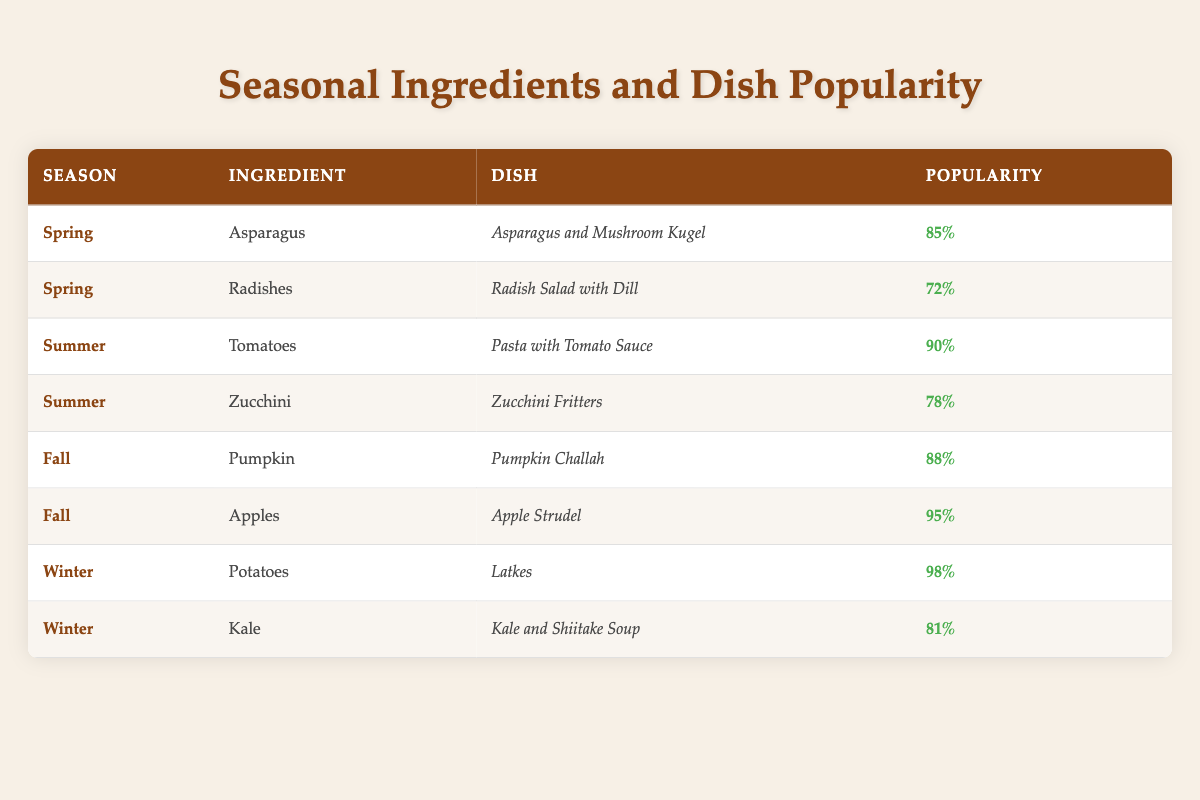What dish has the highest popularity in Spring? The table shows that "Asparagus and Mushroom Kugel" has a popularity of 85%, while "Radish Salad with Dill" has a popularity of 72%. Since 85% is higher than 72%, the dish with the highest popularity in Spring is "Asparagus and Mushroom Kugel."
Answer: Asparagus and Mushroom Kugel What is the popularity of the dish "Apple Strudel"? Looking at the table, "Apple Strudel" is listed under Fall with a popularity of 95%.
Answer: 95% Which season features the ingredient "Zucchini"? The table provides information that "Zucchini" is used in the dish "Zucchini Fritters," which is listed under Summer.
Answer: Summer Is "Latkes" more popular than "Kale and Shiitake Soup"? "Latkes" have a popularity rating of 98%, while "Kale and Shiitake Soup" has 81%. Since 98% is greater than 81%, it is true that "Latkes" are more popular.
Answer: Yes What is the average popularity of dishes in Winter? The popularity ratings for Winter are 98% for "Latkes" and 81% for "Kale and Shiitake Soup." To find the average, we add these two values together: 98 + 81 = 179. Then, we divide the sum by the number of dishes (2): 179 / 2 = 89.5. Therefore, the average popularity of dishes in Winter is 89.5%.
Answer: 89.5 Which ingredient appears most frequently across all seasons? By scanning the table, we see that each ingredient listed is unique to its season with no repetitions across different seasons. Therefore, no ingredient appears more than once across all seasons.
Answer: None What is the total popularity of dishes made with Spring ingredients? The dishes in Spring are "Asparagus and Mushroom Kugel" with a popularity of 85% and "Radish Salad with Dill" with 72%. To find the total popularity, we add these two: 85 + 72 = 157%.
Answer: 157 Are there more dishes with a popularity above 85% than below 85%? From the data, the dishes with popularity over 85% are "Pasta with Tomato Sauce," "Pumpkin Challah," "Apple Strudel," and "Latkes." That totals to 4 dishes. The dishes below 85% are "Asparagus and Mushroom Kugel," "Radish Salad with Dill," "Zucchini Fritters," and "Kale and Shiitake Soup," totaling 4 dishes as well. Since both amounts are equal, the answer is no.
Answer: No 